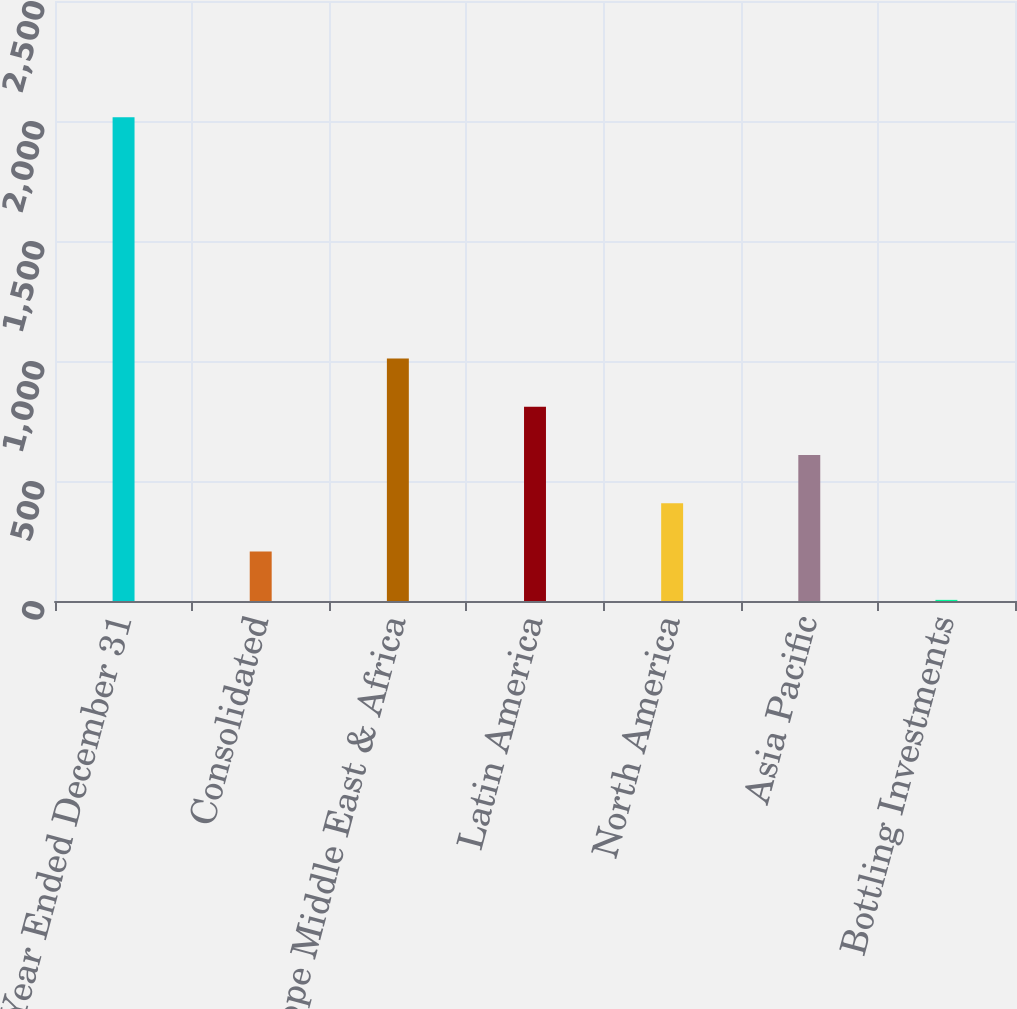Convert chart to OTSL. <chart><loc_0><loc_0><loc_500><loc_500><bar_chart><fcel>Year Ended December 31<fcel>Consolidated<fcel>Europe Middle East & Africa<fcel>Latin America<fcel>North America<fcel>Asia Pacific<fcel>Bottling Investments<nl><fcel>2016<fcel>205.83<fcel>1010.35<fcel>809.22<fcel>406.96<fcel>608.09<fcel>4.7<nl></chart> 